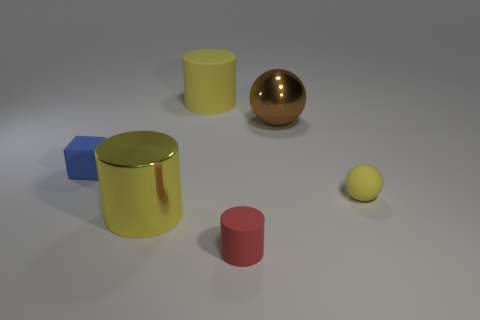Are there any patterns or similarities between the objects that could suggest a theme? Yes, despite their differences in size and color, the objects share simple geometric shapes and smooth textures, which might suggest a theme of geometry or minimalist design. The consistent lighting and muted color palette also contribute to a sense of cohesion and simplicity in the scene. 